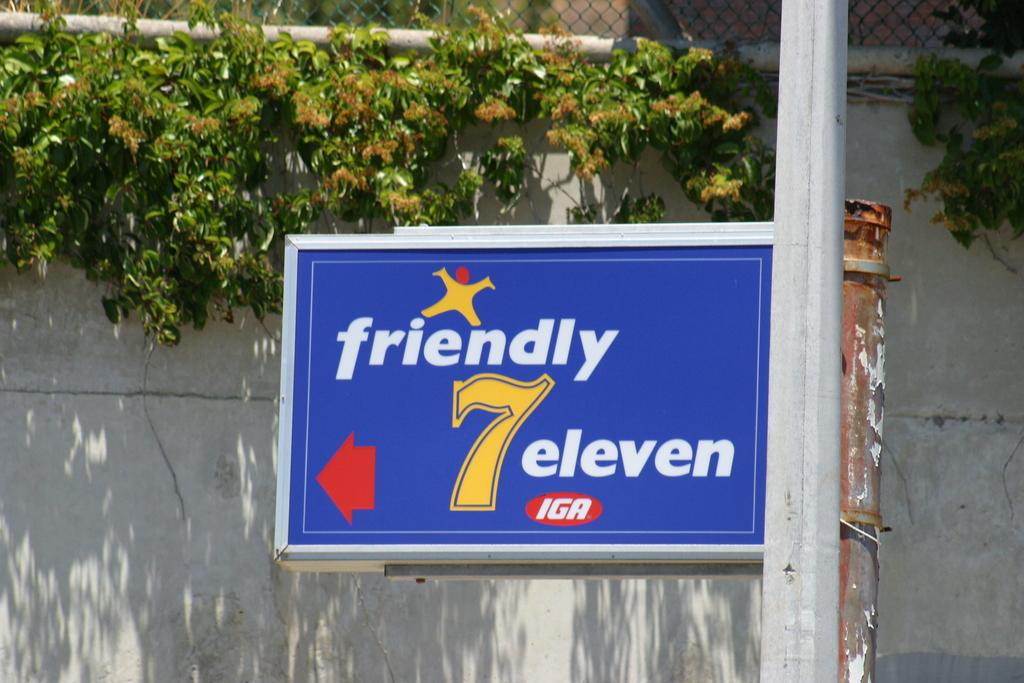What is attached to the pole in the image? There is a board attached to a pole in the image. What can be seen on the backside of the board? There are plants visible on the backside of the board. What type of structure is present in the image? There is a fence in the image. What is another structure visible in the image? There is a wall in the image. What type of marble is used to decorate the fence in the image? There is no marble present in the image; the fence is made of a different material. 